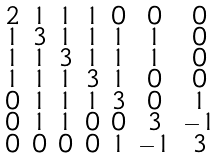<formula> <loc_0><loc_0><loc_500><loc_500>\begin{smallmatrix} 2 & 1 & 1 & 1 & 0 & 0 & 0 \\ 1 & 3 & 1 & 1 & 1 & 1 & 0 \\ 1 & 1 & 3 & 1 & 1 & 1 & 0 \\ 1 & 1 & 1 & 3 & 1 & 0 & 0 \\ 0 & 1 & 1 & 1 & 3 & 0 & 1 \\ 0 & 1 & 1 & 0 & 0 & 3 & - 1 \\ 0 & 0 & 0 & 0 & 1 & - 1 & 3 \end{smallmatrix}</formula> 